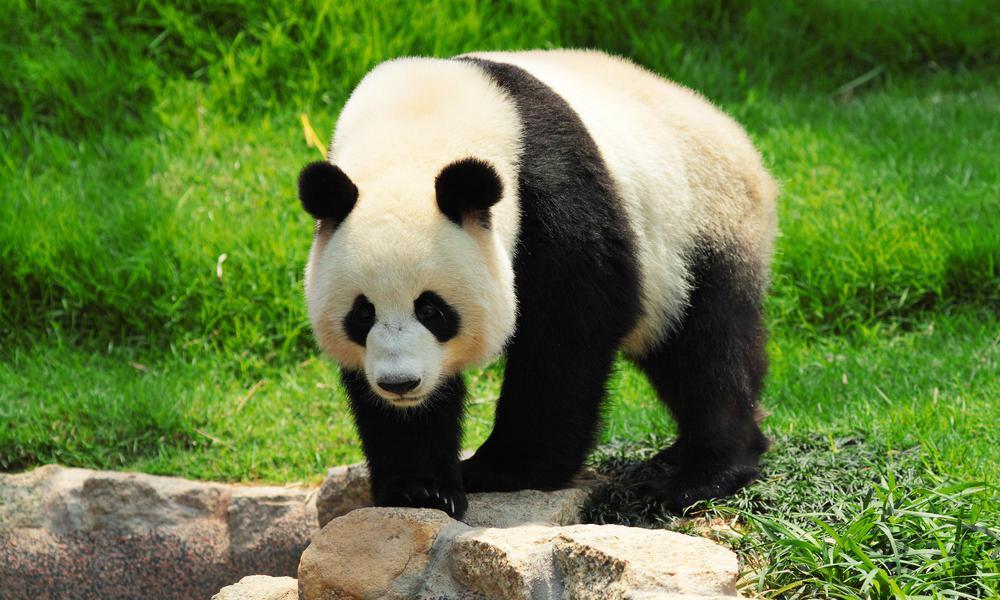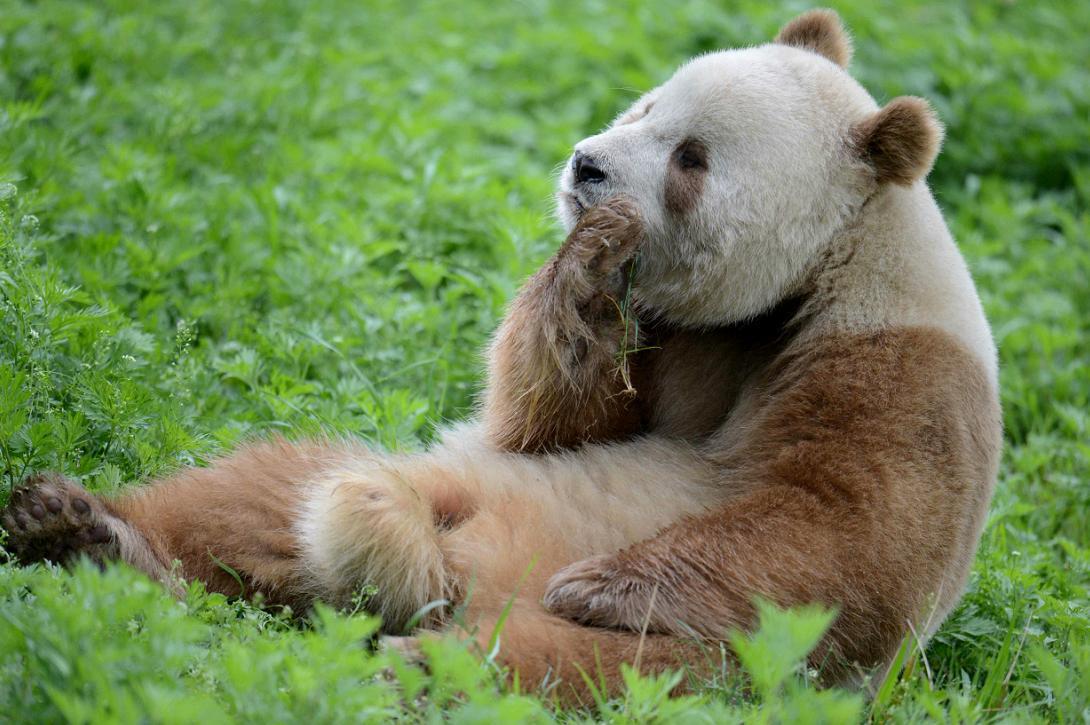The first image is the image on the left, the second image is the image on the right. Examine the images to the left and right. Is the description "Right image shows a panda half sitting, half lying, with legs extended and back curled." accurate? Answer yes or no. Yes. 